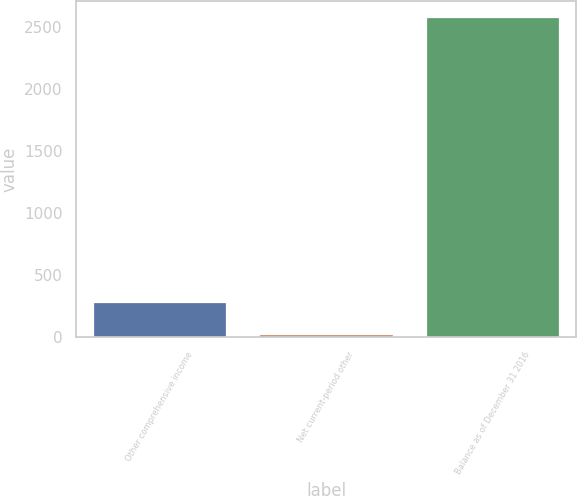<chart> <loc_0><loc_0><loc_500><loc_500><bar_chart><fcel>Other comprehensive income<fcel>Net current-period other<fcel>Balance as of December 31 2016<nl><fcel>281.1<fcel>25<fcel>2586<nl></chart> 